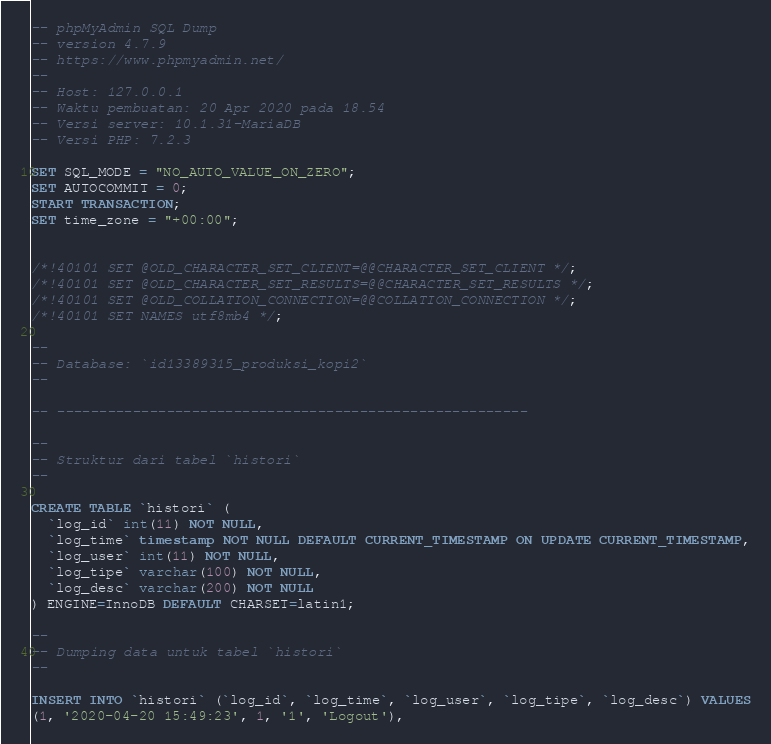Convert code to text. <code><loc_0><loc_0><loc_500><loc_500><_SQL_>-- phpMyAdmin SQL Dump
-- version 4.7.9
-- https://www.phpmyadmin.net/
--
-- Host: 127.0.0.1
-- Waktu pembuatan: 20 Apr 2020 pada 18.54
-- Versi server: 10.1.31-MariaDB
-- Versi PHP: 7.2.3

SET SQL_MODE = "NO_AUTO_VALUE_ON_ZERO";
SET AUTOCOMMIT = 0;
START TRANSACTION;
SET time_zone = "+00:00";


/*!40101 SET @OLD_CHARACTER_SET_CLIENT=@@CHARACTER_SET_CLIENT */;
/*!40101 SET @OLD_CHARACTER_SET_RESULTS=@@CHARACTER_SET_RESULTS */;
/*!40101 SET @OLD_COLLATION_CONNECTION=@@COLLATION_CONNECTION */;
/*!40101 SET NAMES utf8mb4 */;

--
-- Database: `id13389315_produksi_kopi2`
--

-- --------------------------------------------------------

--
-- Struktur dari tabel `histori`
--

CREATE TABLE `histori` (
  `log_id` int(11) NOT NULL,
  `log_time` timestamp NOT NULL DEFAULT CURRENT_TIMESTAMP ON UPDATE CURRENT_TIMESTAMP,
  `log_user` int(11) NOT NULL,
  `log_tipe` varchar(100) NOT NULL,
  `log_desc` varchar(200) NOT NULL
) ENGINE=InnoDB DEFAULT CHARSET=latin1;

--
-- Dumping data untuk tabel `histori`
--

INSERT INTO `histori` (`log_id`, `log_time`, `log_user`, `log_tipe`, `log_desc`) VALUES
(1, '2020-04-20 15:49:23', 1, '1', 'Logout'),</code> 